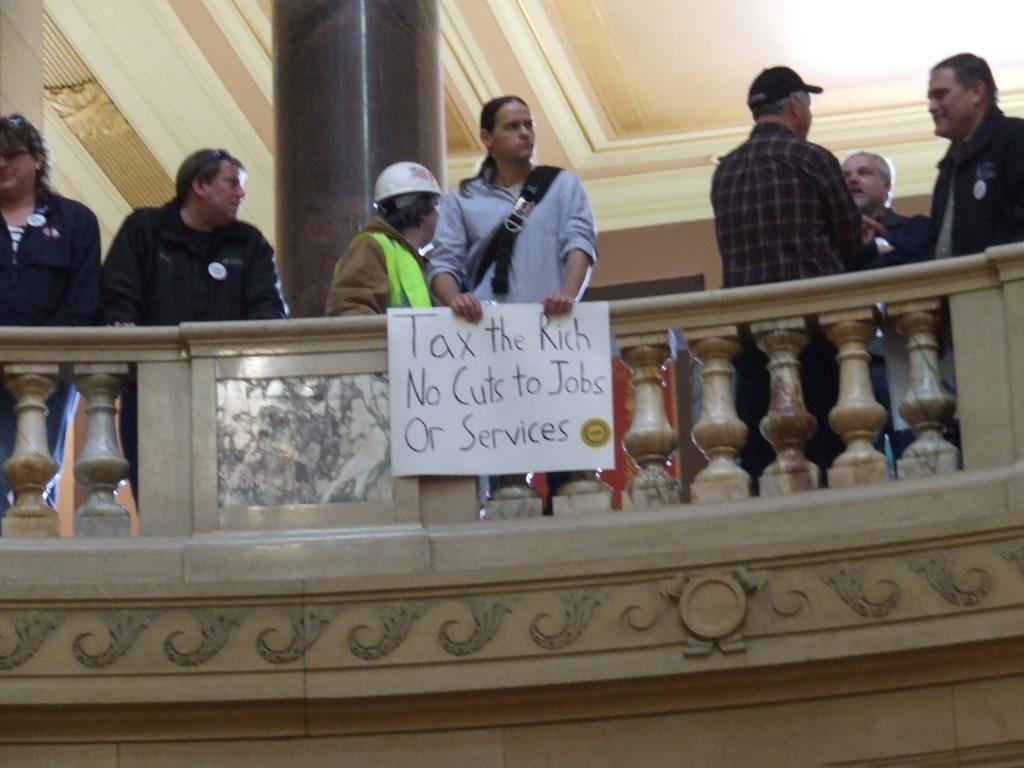What is the main subject of the image? The main subject of the image is a person standing in the middle of the image holding a placard. What are the people around the person with the placard doing? The people standing around the person with the placard are also visible in the image. What can be seen in the middle of the image besides the person with the placard? There appears to be a railing in the middle of the image. How many fish can be seen swimming in the image? There are no fish visible in the image. What type of protest is the person with the placard participating in? The image does not provide any information about the nature of the protest or the message on the placard. 